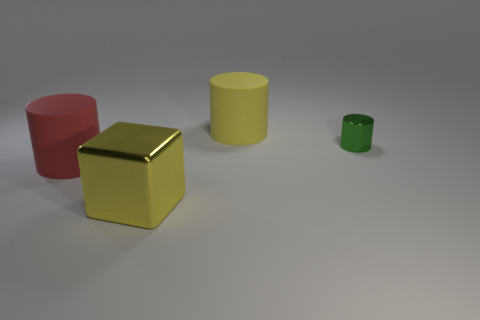Is the color of the cylinder behind the tiny metal thing the same as the big shiny object?
Keep it short and to the point. Yes. What number of other objects are the same color as the block?
Keep it short and to the point. 1. Are there any other things that are the same size as the metallic cylinder?
Offer a very short reply. No. Is the number of things that are in front of the green cylinder greater than the number of large red objects?
Your response must be concise. Yes. Is there a big matte object of the same color as the tiny metal cylinder?
Offer a very short reply. No. What size is the green object?
Offer a very short reply. Small. How many objects are purple metal objects or big red matte cylinders that are behind the metallic cube?
Your answer should be very brief. 1. There is a large rubber cylinder that is to the left of the large rubber cylinder behind the tiny green shiny cylinder; how many big things are behind it?
Your answer should be compact. 1. How many tiny red matte blocks are there?
Provide a short and direct response. 0. Is the size of the yellow object that is behind the yellow block the same as the cube?
Your answer should be very brief. Yes. 